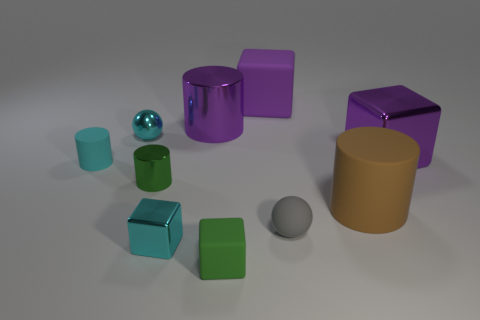What is the material of the small cyan ball that is in front of the large cube to the left of the small ball in front of the tiny green cylinder?
Provide a short and direct response. Metal. How many other objects are there of the same shape as the small cyan rubber object?
Your answer should be very brief. 3. The ball that is behind the purple metal block is what color?
Your response must be concise. Cyan. What number of cyan balls are behind the rubber thing that is behind the purple shiny object that is in front of the small cyan ball?
Make the answer very short. 0. What number of tiny spheres are left of the matte block that is behind the green rubber thing?
Keep it short and to the point. 1. How many green rubber cubes are left of the green cylinder?
Provide a succinct answer. 0. What number of other things are the same size as the brown object?
Offer a very short reply. 3. What size is the cyan thing that is the same shape as the small green rubber thing?
Provide a short and direct response. Small. What is the shape of the cyan metallic thing in front of the green cylinder?
Your answer should be very brief. Cube. What is the color of the tiny sphere that is to the left of the matte cube behind the cyan matte object?
Offer a very short reply. Cyan. 